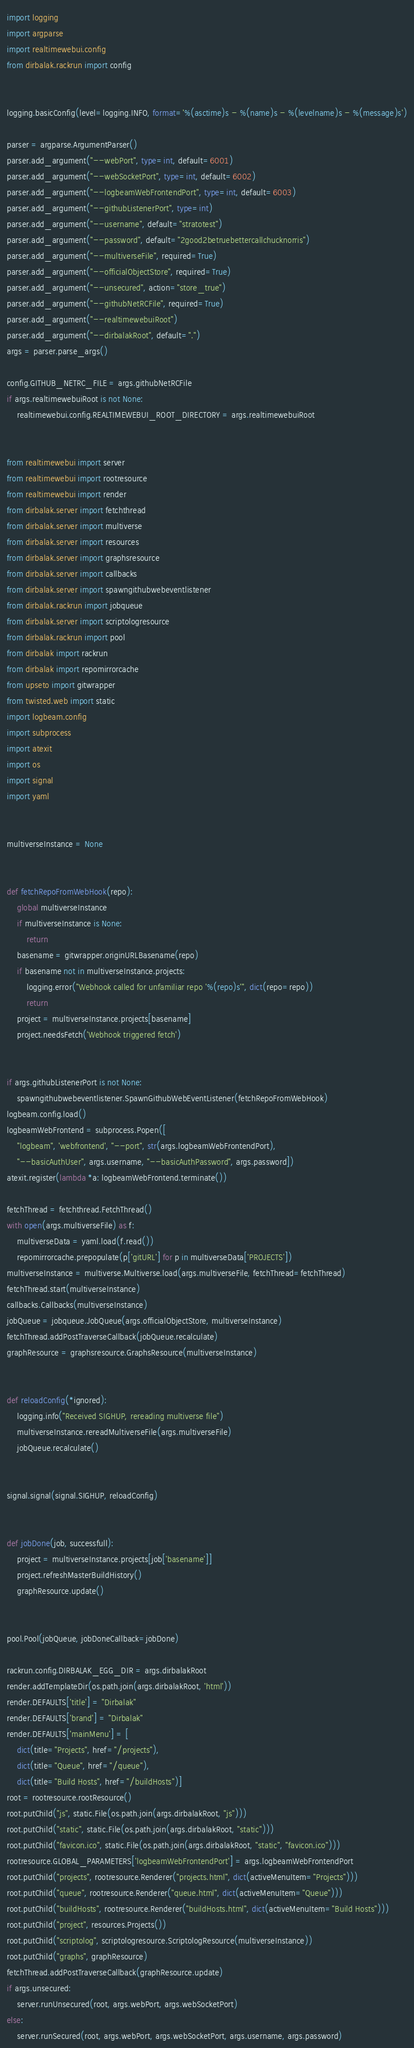Convert code to text. <code><loc_0><loc_0><loc_500><loc_500><_Python_>import logging
import argparse
import realtimewebui.config
from dirbalak.rackrun import config


logging.basicConfig(level=logging.INFO, format='%(asctime)s - %(name)s - %(levelname)s - %(message)s')

parser = argparse.ArgumentParser()
parser.add_argument("--webPort", type=int, default=6001)
parser.add_argument("--webSocketPort", type=int, default=6002)
parser.add_argument("--logbeamWebFrontendPort", type=int, default=6003)
parser.add_argument("--githubListenerPort", type=int)
parser.add_argument("--username", default="stratotest")
parser.add_argument("--password", default="2good2betruebettercallchucknorris")
parser.add_argument("--multiverseFile", required=True)
parser.add_argument("--officialObjectStore", required=True)
parser.add_argument("--unsecured", action="store_true")
parser.add_argument("--githubNetRCFile", required=True)
parser.add_argument("--realtimewebuiRoot")
parser.add_argument("--dirbalakRoot", default=".")
args = parser.parse_args()

config.GITHUB_NETRC_FILE = args.githubNetRCFile
if args.realtimewebuiRoot is not None:
    realtimewebui.config.REALTIMEWEBUI_ROOT_DIRECTORY = args.realtimewebuiRoot


from realtimewebui import server
from realtimewebui import rootresource
from realtimewebui import render
from dirbalak.server import fetchthread
from dirbalak.server import multiverse
from dirbalak.server import resources
from dirbalak.server import graphsresource
from dirbalak.server import callbacks
from dirbalak.server import spawngithubwebeventlistener
from dirbalak.rackrun import jobqueue
from dirbalak.server import scriptologresource
from dirbalak.rackrun import pool
from dirbalak import rackrun
from dirbalak import repomirrorcache
from upseto import gitwrapper
from twisted.web import static
import logbeam.config
import subprocess
import atexit
import os
import signal
import yaml


multiverseInstance = None


def fetchRepoFromWebHook(repo):
    global multiverseInstance
    if multiverseInstance is None:
        return
    basename = gitwrapper.originURLBasename(repo)
    if basename not in multiverseInstance.projects:
        logging.error("Webhook called for unfamiliar repo '%(repo)s'", dict(repo=repo))
        return
    project = multiverseInstance.projects[basename]
    project.needsFetch('Webhook triggered fetch')


if args.githubListenerPort is not None:
    spawngithubwebeventlistener.SpawnGithubWebEventListener(fetchRepoFromWebHook)
logbeam.config.load()
logbeamWebFrontend = subprocess.Popen([
    "logbeam", 'webfrontend', "--port", str(args.logbeamWebFrontendPort),
    "--basicAuthUser", args.username, "--basicAuthPassword", args.password])
atexit.register(lambda *a: logbeamWebFrontend.terminate())

fetchThread = fetchthread.FetchThread()
with open(args.multiverseFile) as f:
    multiverseData = yaml.load(f.read())
    repomirrorcache.prepopulate(p['gitURL'] for p in multiverseData['PROJECTS'])
multiverseInstance = multiverse.Multiverse.load(args.multiverseFile, fetchThread=fetchThread)
fetchThread.start(multiverseInstance)
callbacks.Callbacks(multiverseInstance)
jobQueue = jobqueue.JobQueue(args.officialObjectStore, multiverseInstance)
fetchThread.addPostTraverseCallback(jobQueue.recalculate)
graphResource = graphsresource.GraphsResource(multiverseInstance)


def reloadConfig(*ignored):
    logging.info("Received SIGHUP, rereading multiverse file")
    multiverseInstance.rereadMultiverseFile(args.multiverseFile)
    jobQueue.recalculate()


signal.signal(signal.SIGHUP, reloadConfig)


def jobDone(job, successfull):
    project = multiverseInstance.projects[job['basename']]
    project.refreshMasterBuildHistory()
    graphResource.update()


pool.Pool(jobQueue, jobDoneCallback=jobDone)

rackrun.config.DIRBALAK_EGG_DIR = args.dirbalakRoot
render.addTemplateDir(os.path.join(args.dirbalakRoot, 'html'))
render.DEFAULTS['title'] = "Dirbalak"
render.DEFAULTS['brand'] = "Dirbalak"
render.DEFAULTS['mainMenu'] = [
    dict(title="Projects", href="/projects"),
    dict(title="Queue", href="/queue"),
    dict(title="Build Hosts", href="/buildHosts")]
root = rootresource.rootResource()
root.putChild("js", static.File(os.path.join(args.dirbalakRoot, "js")))
root.putChild("static", static.File(os.path.join(args.dirbalakRoot, "static")))
root.putChild("favicon.ico", static.File(os.path.join(args.dirbalakRoot, "static", "favicon.ico")))
rootresource.GLOBAL_PARAMETERS['logbeamWebFrontendPort'] = args.logbeamWebFrontendPort
root.putChild("projects", rootresource.Renderer("projects.html", dict(activeMenuItem="Projects")))
root.putChild("queue", rootresource.Renderer("queue.html", dict(activeMenuItem="Queue")))
root.putChild("buildHosts", rootresource.Renderer("buildHosts.html", dict(activeMenuItem="Build Hosts")))
root.putChild("project", resources.Projects())
root.putChild("scriptolog", scriptologresource.ScriptologResource(multiverseInstance))
root.putChild("graphs", graphResource)
fetchThread.addPostTraverseCallback(graphResource.update)
if args.unsecured:
    server.runUnsecured(root, args.webPort, args.webSocketPort)
else:
    server.runSecured(root, args.webPort, args.webSocketPort, args.username, args.password)
</code> 